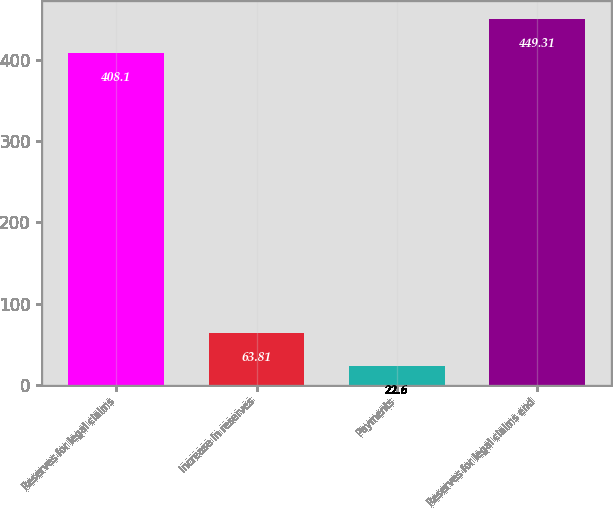Convert chart. <chart><loc_0><loc_0><loc_500><loc_500><bar_chart><fcel>Reserves for legal claims<fcel>Increase in reserves<fcel>Payments<fcel>Reserves for legal claims end<nl><fcel>408.1<fcel>63.81<fcel>22.6<fcel>449.31<nl></chart> 